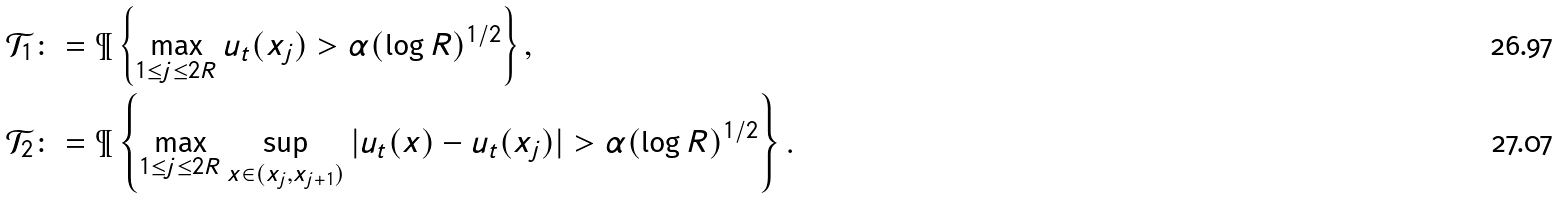Convert formula to latex. <formula><loc_0><loc_0><loc_500><loc_500>\mathcal { T } _ { 1 } & \colon = \P \left \{ \max _ { 1 \leq j \leq 2 R } u _ { t } ( x _ { j } ) > \alpha ( \log R ) ^ { 1 / 2 } \right \} , \\ \mathcal { T } _ { 2 } & \colon = \P \left \{ \max _ { 1 \leq j \leq 2 R } \sup _ { x \in ( x _ { j } , x _ { j + 1 } ) } | u _ { t } ( x ) - u _ { t } ( x _ { j } ) | > \alpha ( \log R ) ^ { 1 / 2 } \right \} .</formula> 